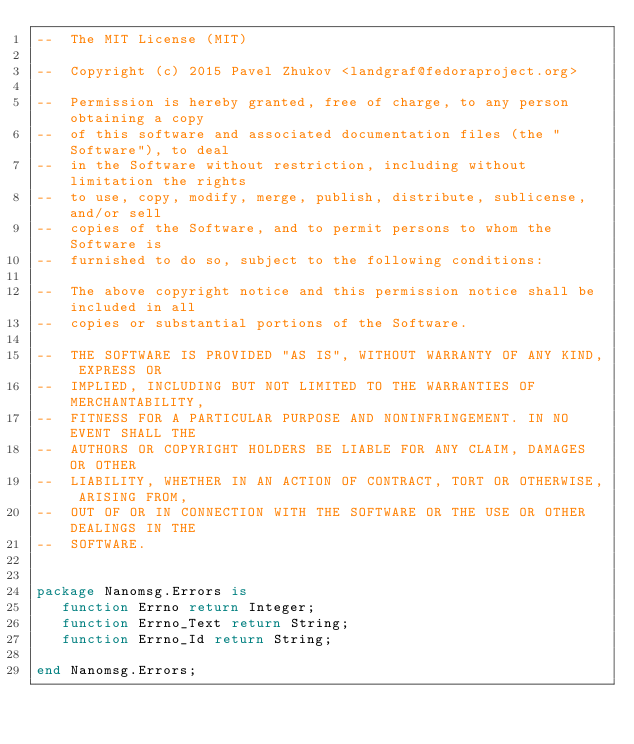<code> <loc_0><loc_0><loc_500><loc_500><_Ada_>--  The MIT License (MIT)

--  Copyright (c) 2015 Pavel Zhukov <landgraf@fedoraproject.org>

--  Permission is hereby granted, free of charge, to any person obtaining a copy
--  of this software and associated documentation files (the "Software"), to deal
--  in the Software without restriction, including without limitation the rights
--  to use, copy, modify, merge, publish, distribute, sublicense, and/or sell
--  copies of the Software, and to permit persons to whom the Software is
--  furnished to do so, subject to the following conditions:

--  The above copyright notice and this permission notice shall be included in all
--  copies or substantial portions of the Software.

--  THE SOFTWARE IS PROVIDED "AS IS", WITHOUT WARRANTY OF ANY KIND, EXPRESS OR
--  IMPLIED, INCLUDING BUT NOT LIMITED TO THE WARRANTIES OF MERCHANTABILITY,
--  FITNESS FOR A PARTICULAR PURPOSE AND NONINFRINGEMENT. IN NO EVENT SHALL THE
--  AUTHORS OR COPYRIGHT HOLDERS BE LIABLE FOR ANY CLAIM, DAMAGES OR OTHER
--  LIABILITY, WHETHER IN AN ACTION OF CONTRACT, TORT OR OTHERWISE, ARISING FROM,
--  OUT OF OR IN CONNECTION WITH THE SOFTWARE OR THE USE OR OTHER DEALINGS IN THE
--  SOFTWARE.


package Nanomsg.Errors is
   function Errno return Integer;
   function Errno_Text return String;
   function Errno_Id return String;
   
end Nanomsg.Errors;
</code> 